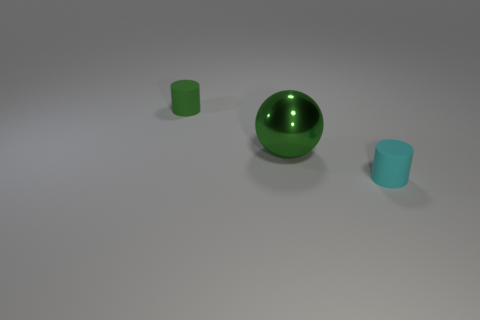How many cylinders have the same material as the cyan thing?
Your answer should be compact. 1. Are there an equal number of cyan cylinders on the right side of the large ball and small rubber cylinders?
Keep it short and to the point. No. There is a cylinder that is the same color as the metal sphere; what material is it?
Offer a terse response. Rubber. There is a green metallic thing; is it the same size as the matte thing that is in front of the green cylinder?
Your answer should be very brief. No. What number of other objects are the same size as the green ball?
Your response must be concise. 0. What number of other objects are the same color as the big metal ball?
Provide a short and direct response. 1. Are there any other things that are the same size as the green matte thing?
Provide a short and direct response. Yes. How many other things are there of the same shape as the green metal object?
Ensure brevity in your answer.  0. Does the cyan rubber thing have the same size as the green rubber cylinder?
Your answer should be very brief. Yes. Is there a big red cube?
Make the answer very short. No. 